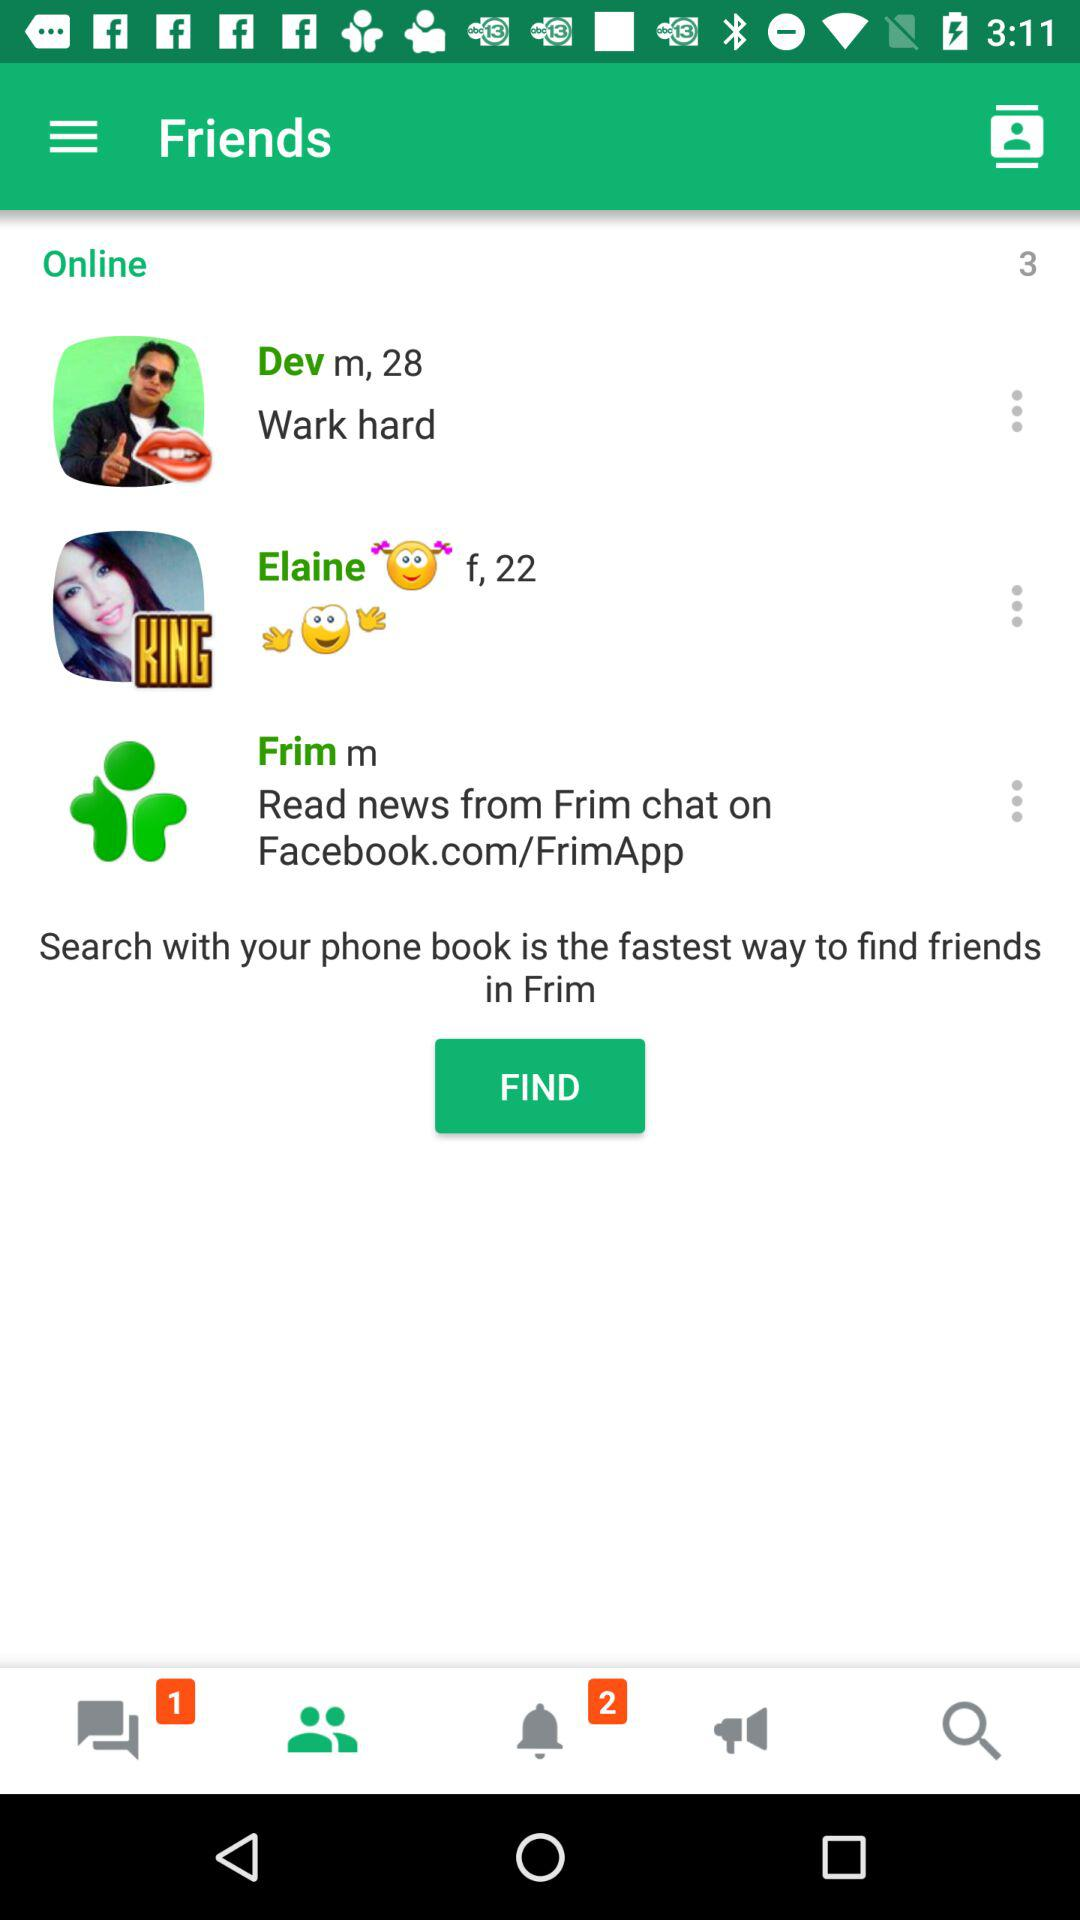What is the gender of Dev? The gender is male. 